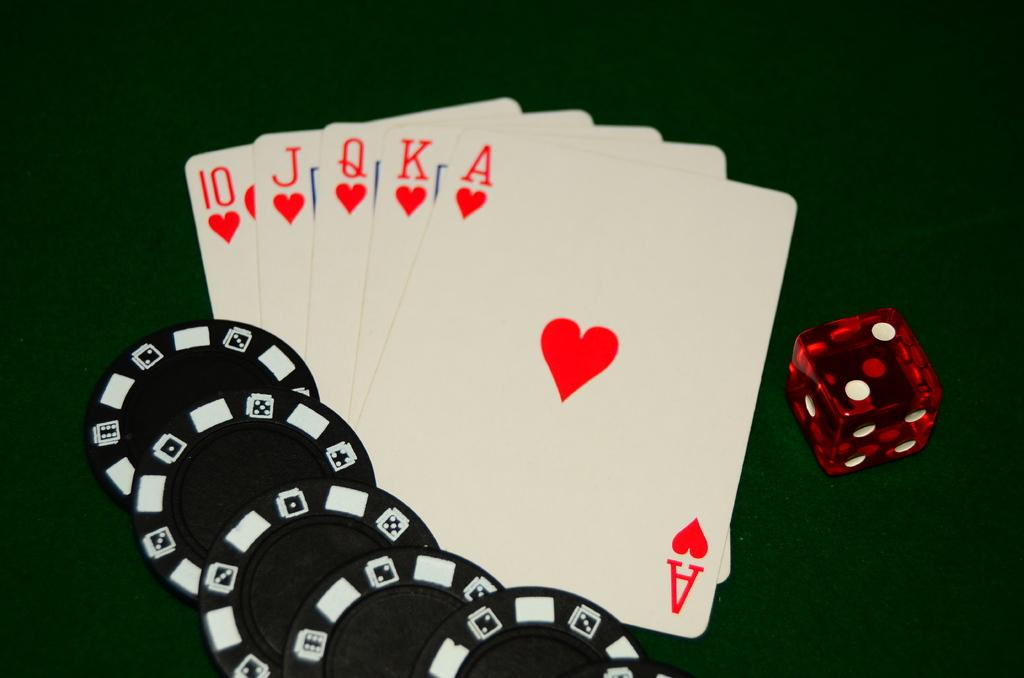<image>
Provide a brief description of the given image. Poker chips, dice and royal flush on a table. 